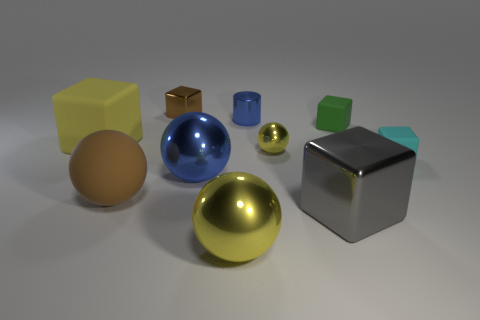Subtract all gray metal cubes. How many cubes are left? 4 Subtract all cyan blocks. How many yellow balls are left? 2 Subtract all cyan blocks. How many blocks are left? 4 Subtract 1 balls. How many balls are left? 3 Subtract all cylinders. How many objects are left? 9 Add 5 green objects. How many green objects are left? 6 Add 5 purple metal things. How many purple metal things exist? 5 Subtract 0 yellow cylinders. How many objects are left? 10 Subtract all purple cubes. Subtract all yellow spheres. How many cubes are left? 5 Subtract all tiny blue metallic cylinders. Subtract all red objects. How many objects are left? 9 